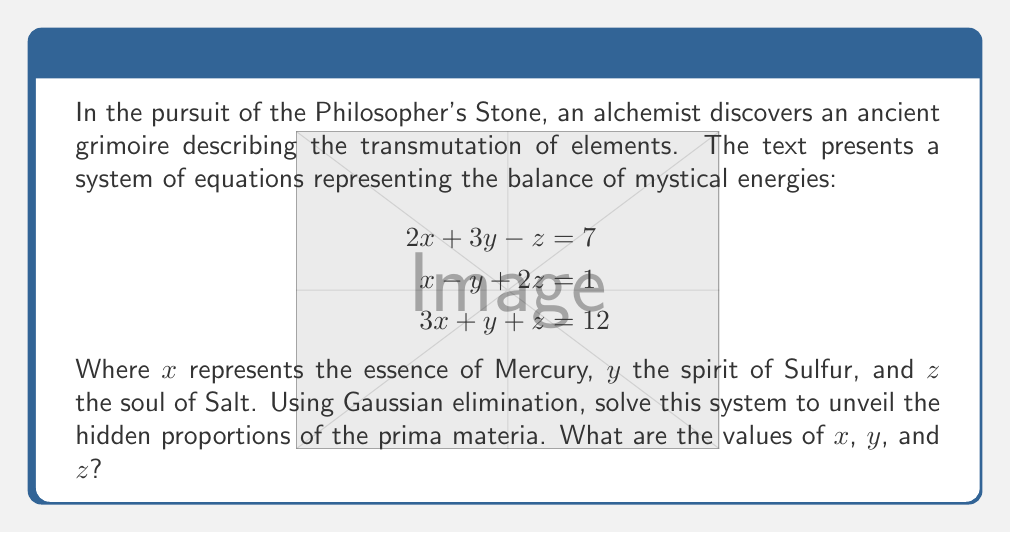Could you help me with this problem? To solve this system using Gaussian elimination, we'll follow these esoteric steps:

1) First, we write the augmented matrix:

   $$
   \begin{bmatrix}
   2 & 3 & -1 & 7 \\
   1 & -1 & 2 & 1 \\
   3 & 1 & 1 & 12
   \end{bmatrix}
   $$

2) We'll use R1 as our pivot row. Subtract 1/2 R1 from R2:

   $$
   \begin{bmatrix}
   2 & 3 & -1 & 7 \\
   0 & -\frac{5}{2} & \frac{5}{2} & -\frac{5}{2} \\
   3 & 1 & 1 & 12
   \end{bmatrix}
   $$

3) Subtract 3/2 R1 from R3:

   $$
   \begin{bmatrix}
   2 & 3 & -1 & 7 \\
   0 & -\frac{5}{2} & \frac{5}{2} & -\frac{5}{2} \\
   0 & -\frac{7}{2} & \frac{5}{2} & \frac{3}{2}
   \end{bmatrix}
   $$

4) Now use R2 as the pivot. Add 7/5 R2 to R3:

   $$
   \begin{bmatrix}
   2 & 3 & -1 & 7 \\
   0 & -\frac{5}{2} & \frac{5}{2} & -\frac{5}{2} \\
   0 & 0 & 4 & -1
   \end{bmatrix}
   $$

5) We now have an upper triangular matrix. Solve for z:

   $4z = -1$
   $z = -\frac{1}{4}$

6) Substitute z into R2:

   $-\frac{5}{2}y + \frac{5}{2}(-\frac{1}{4}) = -\frac{5}{2}$
   $-\frac{5}{2}y - \frac{5}{8} = -\frac{5}{2}$
   $-\frac{5}{2}y = -\frac{15}{8}$
   $y = \frac{3}{4}$

7) Finally, substitute y and z into R1:

   $2x + 3(\frac{3}{4}) - (-\frac{1}{4}) = 7$
   $2x + \frac{9}{4} + \frac{1}{4} = 7$
   $2x = \frac{21}{4}$
   $x = \frac{21}{8}$

Thus, we have unveiled the hidden proportions of the prima materia.
Answer: $x = \frac{21}{8}, y = \frac{3}{4}, z = -\frac{1}{4}$ 